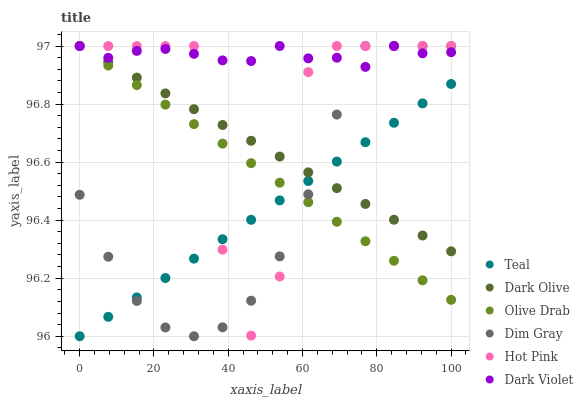Does Teal have the minimum area under the curve?
Answer yes or no. Yes. Does Dark Violet have the maximum area under the curve?
Answer yes or no. Yes. Does Dark Olive have the minimum area under the curve?
Answer yes or no. No. Does Dark Olive have the maximum area under the curve?
Answer yes or no. No. Is Olive Drab the smoothest?
Answer yes or no. Yes. Is Hot Pink the roughest?
Answer yes or no. Yes. Is Dark Olive the smoothest?
Answer yes or no. No. Is Dark Olive the roughest?
Answer yes or no. No. Does Teal have the lowest value?
Answer yes or no. Yes. Does Dark Olive have the lowest value?
Answer yes or no. No. Does Olive Drab have the highest value?
Answer yes or no. Yes. Does Teal have the highest value?
Answer yes or no. No. Is Teal less than Dark Violet?
Answer yes or no. Yes. Is Dark Violet greater than Teal?
Answer yes or no. Yes. Does Dim Gray intersect Olive Drab?
Answer yes or no. Yes. Is Dim Gray less than Olive Drab?
Answer yes or no. No. Is Dim Gray greater than Olive Drab?
Answer yes or no. No. Does Teal intersect Dark Violet?
Answer yes or no. No. 